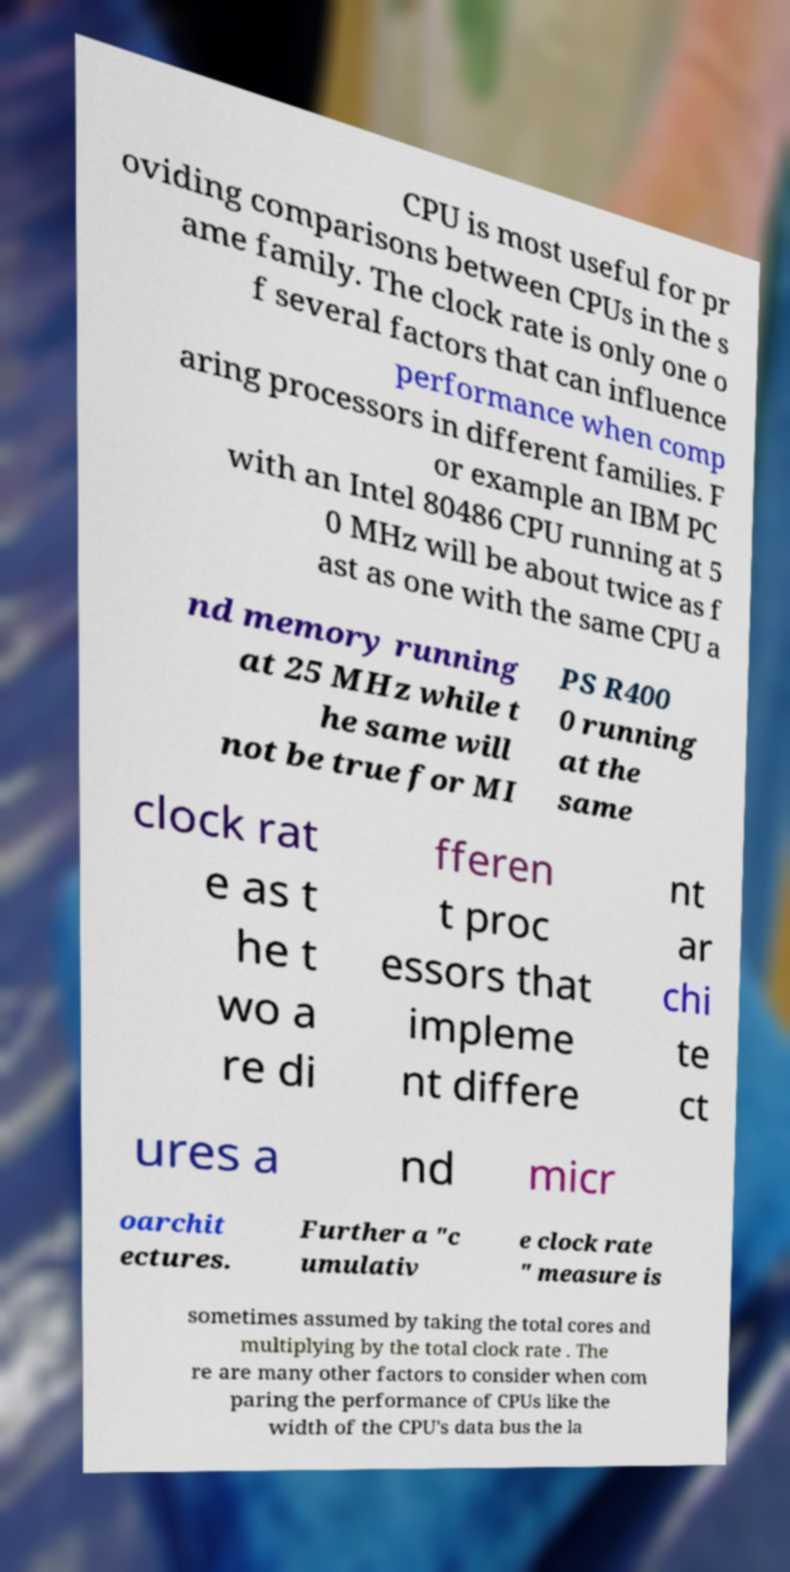Please identify and transcribe the text found in this image. CPU is most useful for pr oviding comparisons between CPUs in the s ame family. The clock rate is only one o f several factors that can influence performance when comp aring processors in different families. F or example an IBM PC with an Intel 80486 CPU running at 5 0 MHz will be about twice as f ast as one with the same CPU a nd memory running at 25 MHz while t he same will not be true for MI PS R400 0 running at the same clock rat e as t he t wo a re di fferen t proc essors that impleme nt differe nt ar chi te ct ures a nd micr oarchit ectures. Further a "c umulativ e clock rate " measure is sometimes assumed by taking the total cores and multiplying by the total clock rate . The re are many other factors to consider when com paring the performance of CPUs like the width of the CPU's data bus the la 